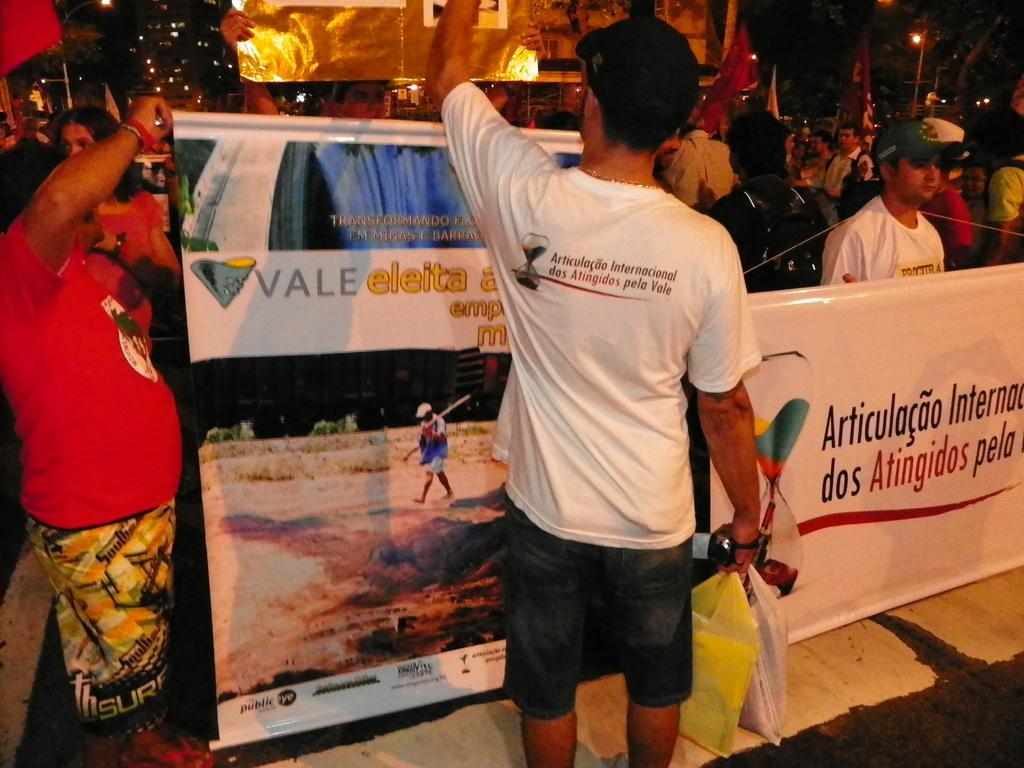Describe this image in one or two sentences. In this picture we can see a man in the white t shirt is holding polythene bags. In front of the man there are banners and groups of people are standing, poles with lights, flags, building and other things. 